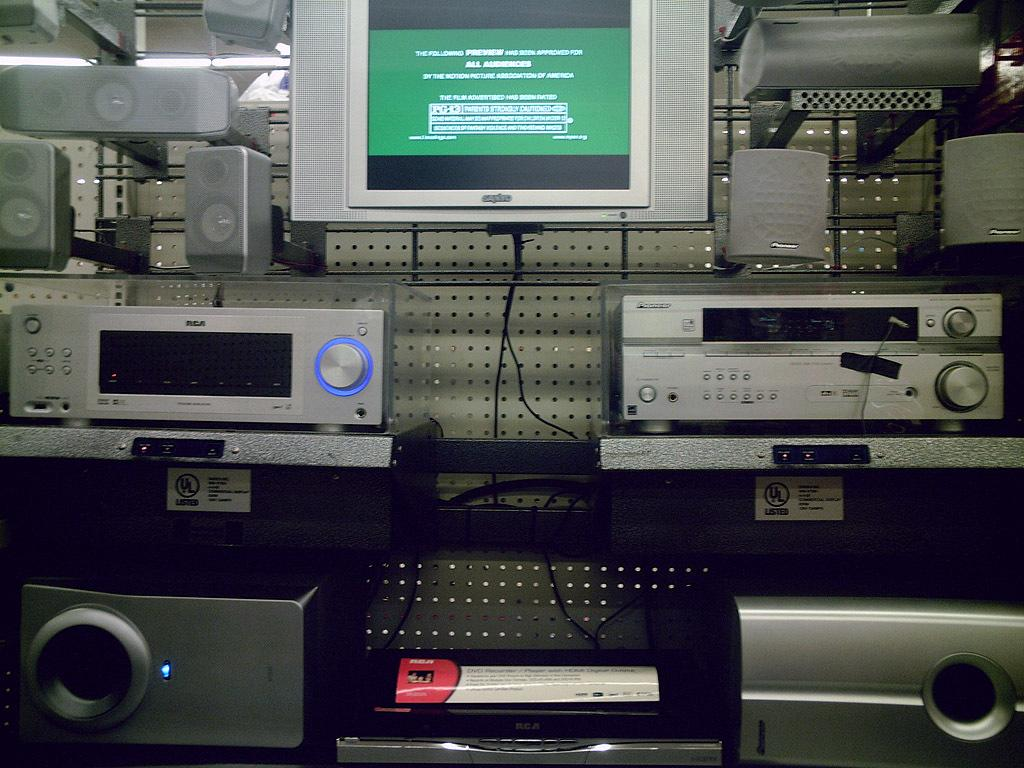<image>
Offer a succinct explanation of the picture presented. An approval rating for everyone is shown on the television screen. 